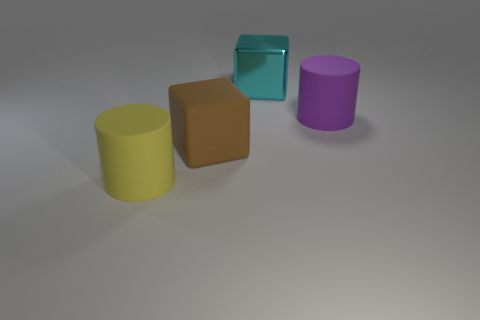Add 2 big cyan metallic cubes. How many objects exist? 6 Subtract 1 brown cubes. How many objects are left? 3 Subtract all brown blocks. Subtract all large cyan metal cubes. How many objects are left? 2 Add 3 big metallic objects. How many big metallic objects are left? 4 Add 2 large cyan cubes. How many large cyan cubes exist? 3 